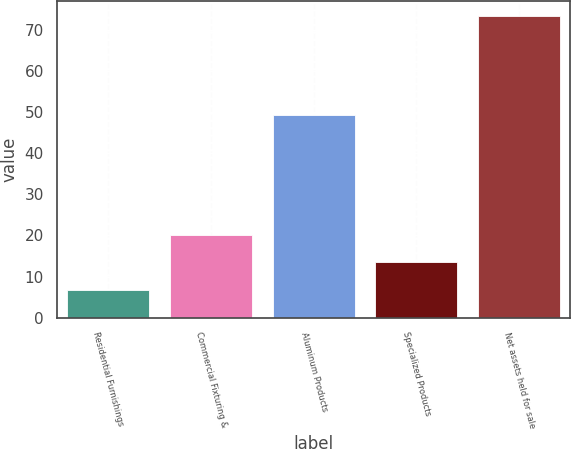Convert chart. <chart><loc_0><loc_0><loc_500><loc_500><bar_chart><fcel>Residential Furnishings<fcel>Commercial Fixturing &<fcel>Aluminum Products<fcel>Specialized Products<fcel>Net assets held for sale<nl><fcel>6.8<fcel>20.12<fcel>49.2<fcel>13.46<fcel>73.4<nl></chart> 